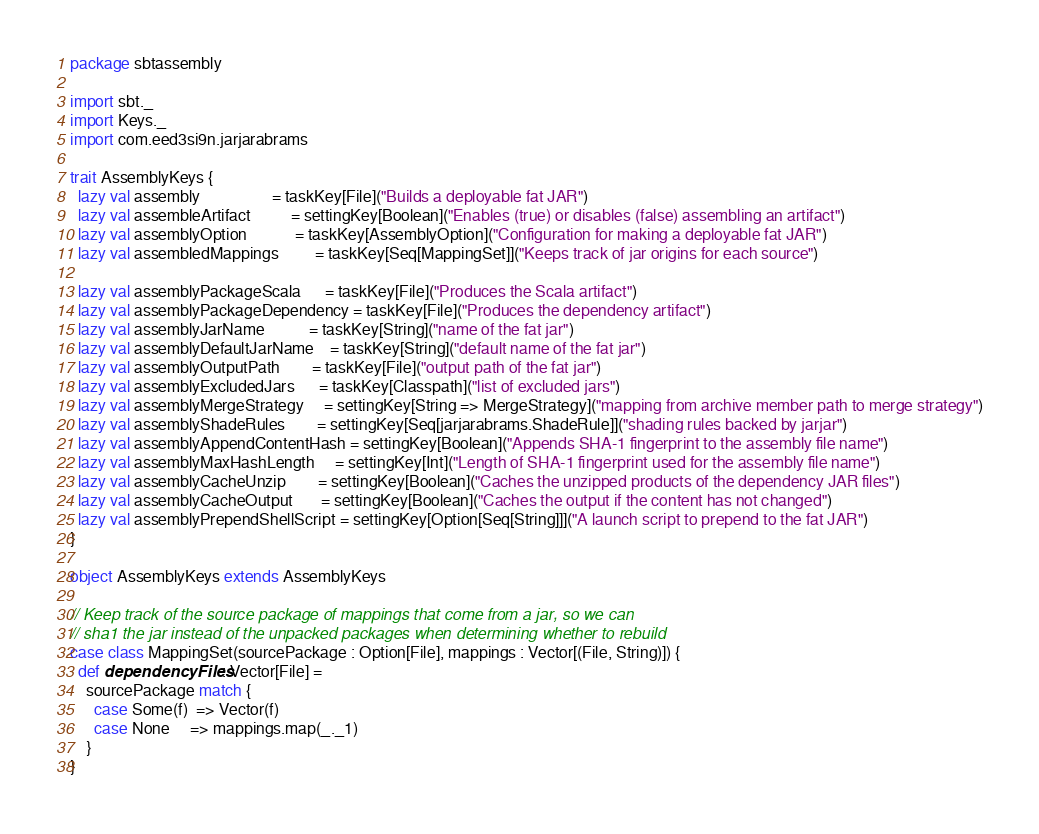Convert code to text. <code><loc_0><loc_0><loc_500><loc_500><_Scala_>package sbtassembly

import sbt._
import Keys._
import com.eed3si9n.jarjarabrams

trait AssemblyKeys {
  lazy val assembly                  = taskKey[File]("Builds a deployable fat JAR")
  lazy val assembleArtifact          = settingKey[Boolean]("Enables (true) or disables (false) assembling an artifact")
  lazy val assemblyOption            = taskKey[AssemblyOption]("Configuration for making a deployable fat JAR")
  lazy val assembledMappings         = taskKey[Seq[MappingSet]]("Keeps track of jar origins for each source")

  lazy val assemblyPackageScala      = taskKey[File]("Produces the Scala artifact")
  lazy val assemblyPackageDependency = taskKey[File]("Produces the dependency artifact")
  lazy val assemblyJarName           = taskKey[String]("name of the fat jar")
  lazy val assemblyDefaultJarName    = taskKey[String]("default name of the fat jar")
  lazy val assemblyOutputPath        = taskKey[File]("output path of the fat jar")
  lazy val assemblyExcludedJars      = taskKey[Classpath]("list of excluded jars")
  lazy val assemblyMergeStrategy     = settingKey[String => MergeStrategy]("mapping from archive member path to merge strategy")
  lazy val assemblyShadeRules        = settingKey[Seq[jarjarabrams.ShadeRule]]("shading rules backed by jarjar")
  lazy val assemblyAppendContentHash = settingKey[Boolean]("Appends SHA-1 fingerprint to the assembly file name")
  lazy val assemblyMaxHashLength     = settingKey[Int]("Length of SHA-1 fingerprint used for the assembly file name")
  lazy val assemblyCacheUnzip        = settingKey[Boolean]("Caches the unzipped products of the dependency JAR files")
  lazy val assemblyCacheOutput       = settingKey[Boolean]("Caches the output if the content has not changed")
  lazy val assemblyPrependShellScript = settingKey[Option[Seq[String]]]("A launch script to prepend to the fat JAR")
}

object AssemblyKeys extends AssemblyKeys

// Keep track of the source package of mappings that come from a jar, so we can
// sha1 the jar instead of the unpacked packages when determining whether to rebuild
case class MappingSet(sourcePackage : Option[File], mappings : Vector[(File, String)]) {
  def dependencyFiles: Vector[File] =
    sourcePackage match {
      case Some(f)  => Vector(f)
      case None     => mappings.map(_._1)
    }
}
</code> 